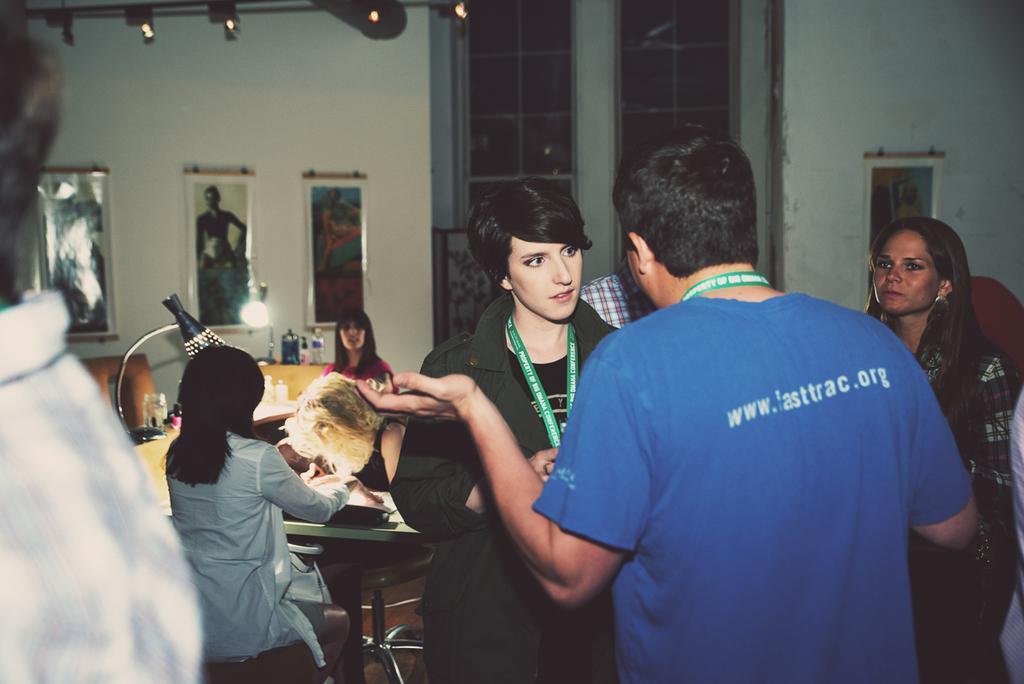Please provide a concise description of this image. On the background we can see door, photo frames over a wall. Here we can see few persons sitting on chairs. These are lights and on the table we can see water bottle. We can see few persons standing here. 